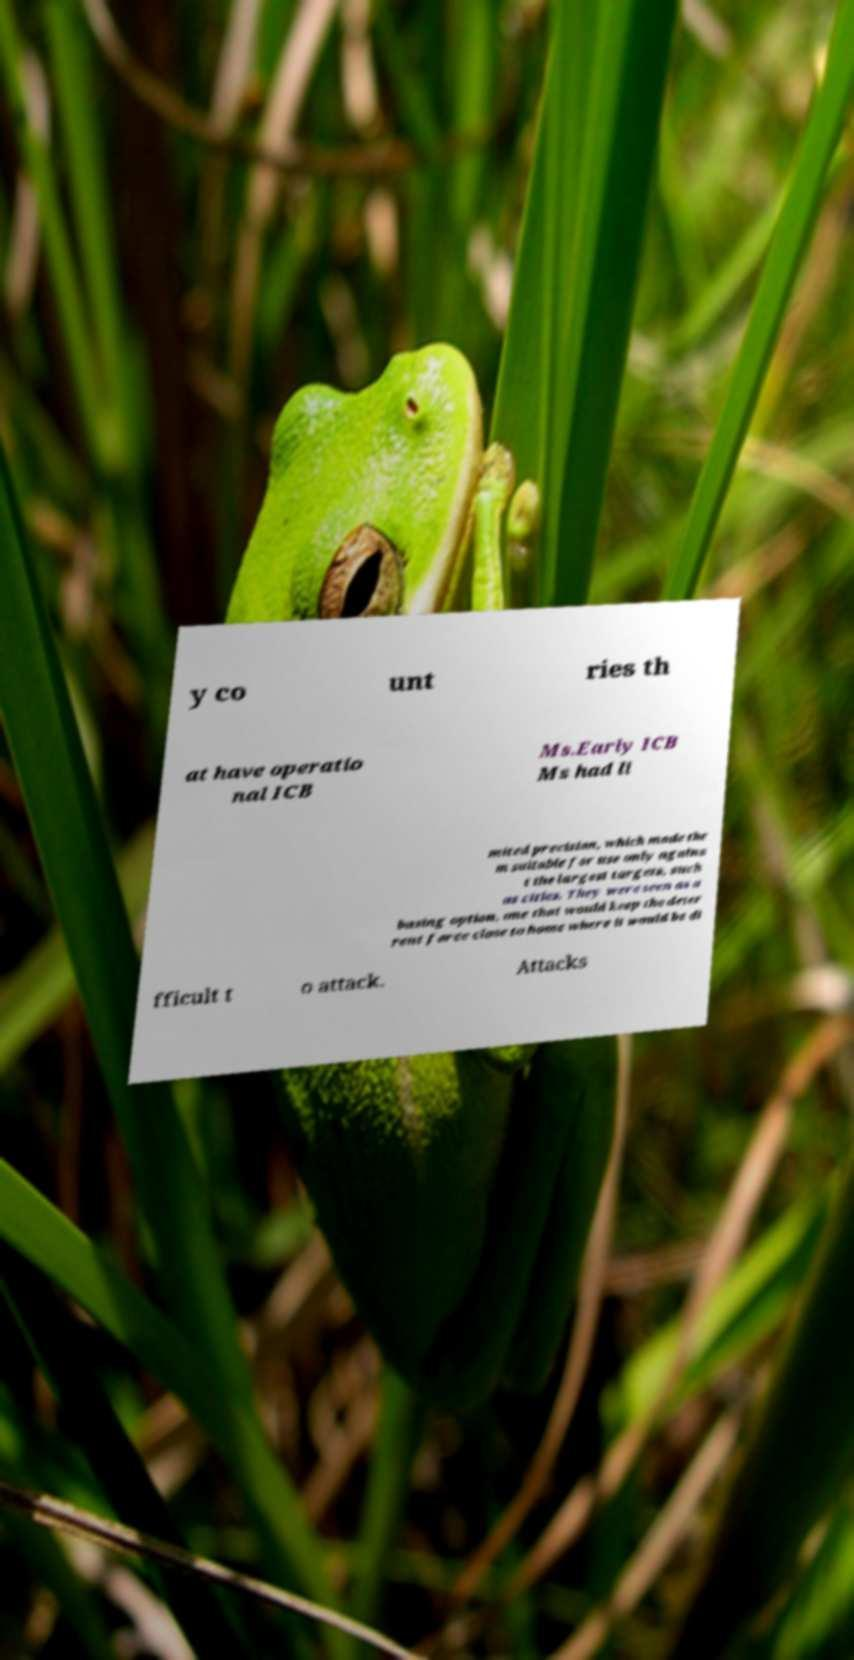There's text embedded in this image that I need extracted. Can you transcribe it verbatim? y co unt ries th at have operatio nal ICB Ms.Early ICB Ms had li mited precision, which made the m suitable for use only agains t the largest targets, such as cities. They were seen as a basing option, one that would keep the deter rent force close to home where it would be di fficult t o attack. Attacks 